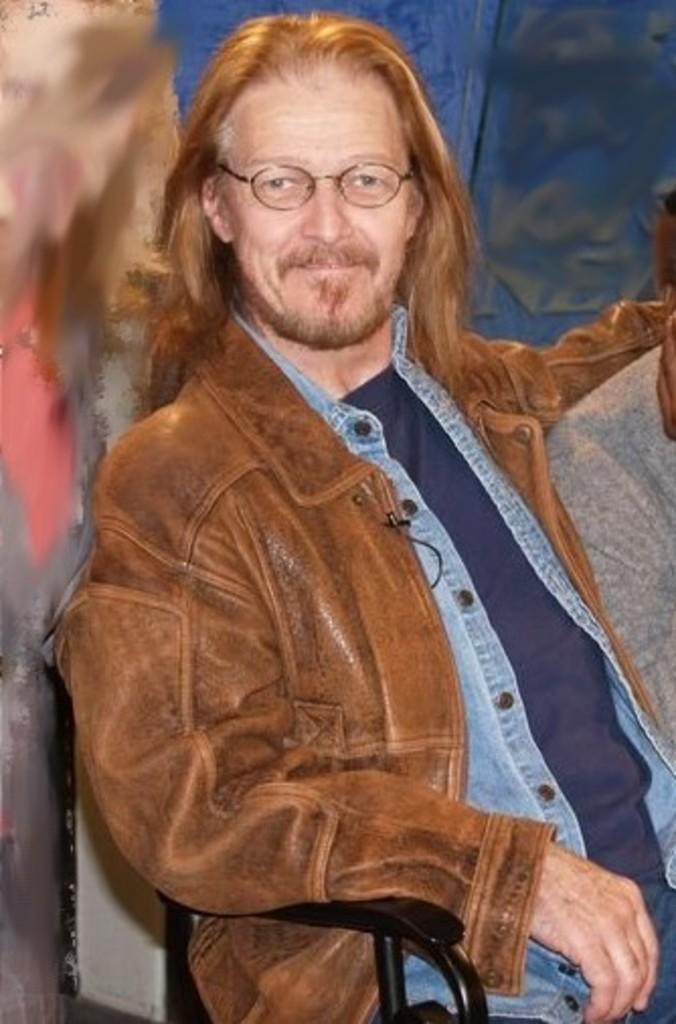What is present in the image? There is a person in the image. What is the person doing in the image? The person is sitting on a chair. What type of tent can be seen in the background of the image? There is no tent present in the image; it only features a person sitting on a chair. 